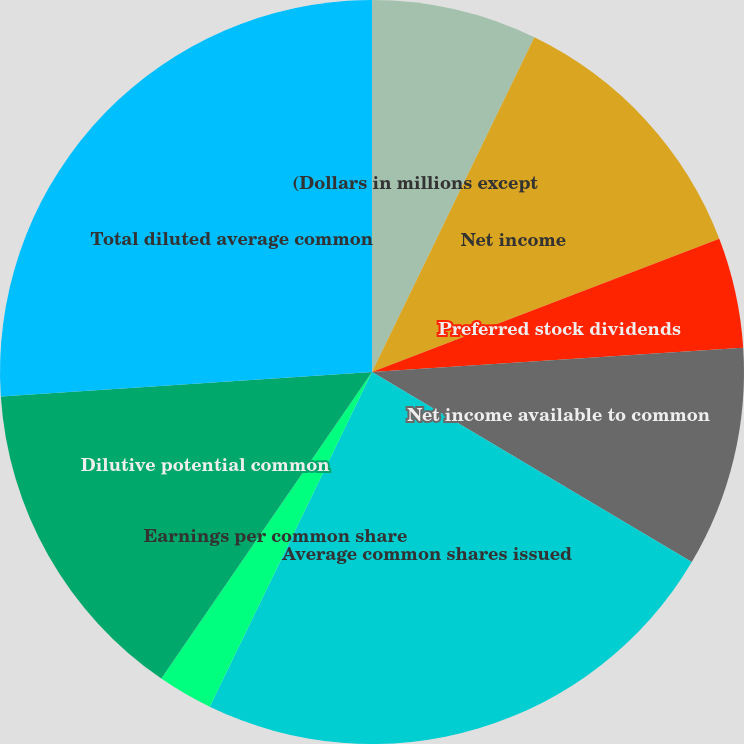<chart> <loc_0><loc_0><loc_500><loc_500><pie_chart><fcel>(Dollars in millions except<fcel>Net income<fcel>Preferred stock dividends<fcel>Net income available to common<fcel>Average common shares issued<fcel>Earnings per common share<fcel>Dilutive potential common<fcel>Total diluted average common<fcel>Diluted earnings per common<nl><fcel>7.19%<fcel>11.98%<fcel>4.79%<fcel>9.58%<fcel>23.65%<fcel>2.4%<fcel>14.37%<fcel>26.05%<fcel>0.0%<nl></chart> 